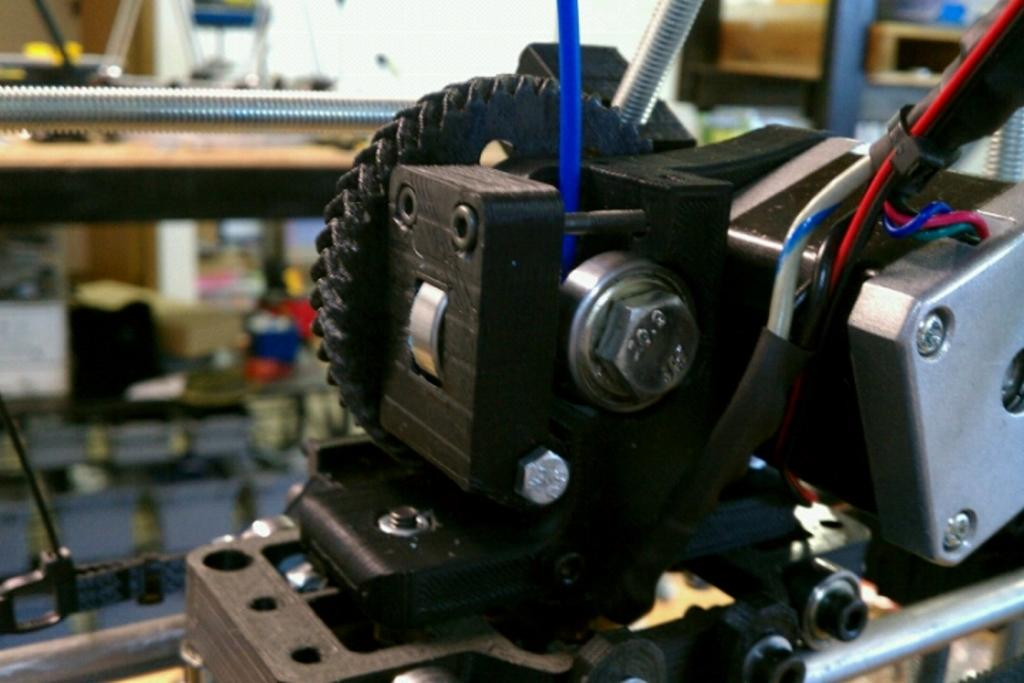What is the main subject in the foreground of the image? There is an electronic equipment in the foreground of the image. Can you describe the objects on the table in the background of the image? Unfortunately, the provided facts do not give any information about the objects on the table in the background. How many ducks are visible in the image? There are no ducks present in the image. 